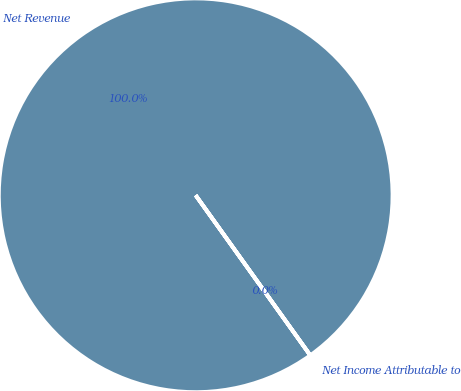Convert chart to OTSL. <chart><loc_0><loc_0><loc_500><loc_500><pie_chart><fcel>Net Revenue<fcel>Net Income Attributable to<nl><fcel>99.99%<fcel>0.01%<nl></chart> 